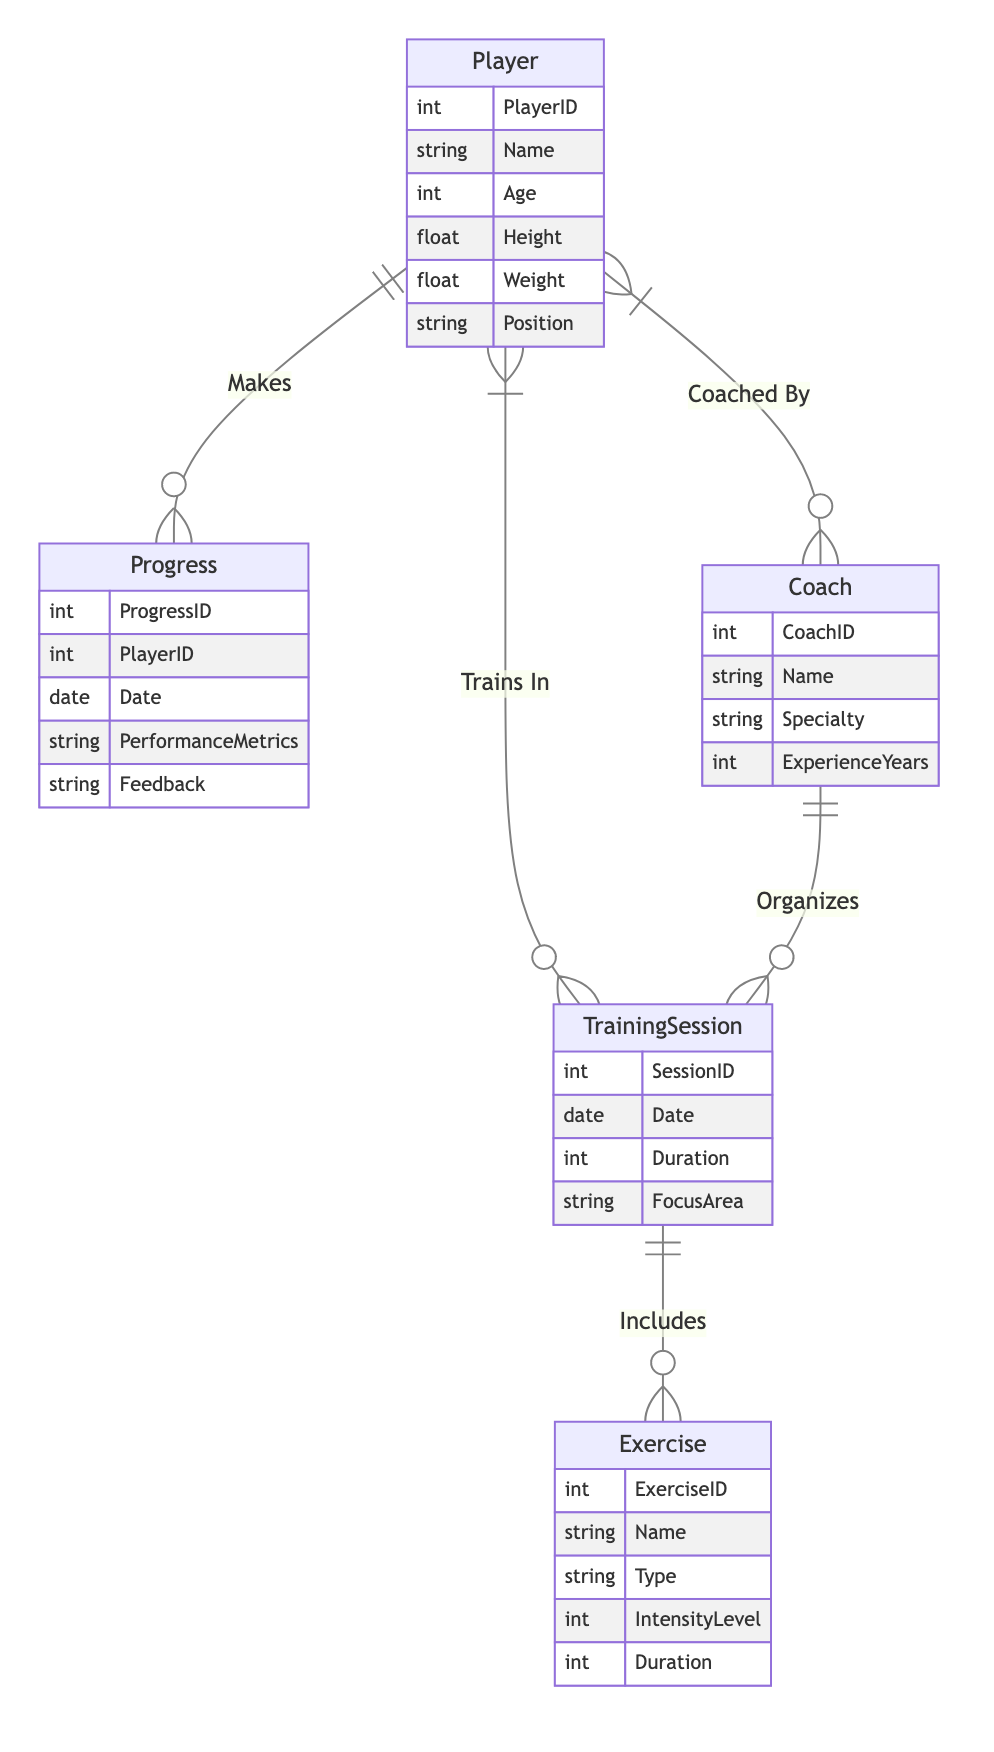What is the relationship between Player and Coach? The diagram indicates a many-to-many relationship between Player and Coach, which means that multiple players can be coached by multiple coaches and vice versa.
Answer: many-to-many How many attributes does the Player entity have? The Player entity consists of six attributes: PlayerID, Name, Age, Height, Weight, and Position.
Answer: six What is the focus area of TrainingSession? The attributes list for TrainingSession includes FocusArea, which indicates that each training session is categorized by a specific focus area, though the specific values are not provided in the diagram.
Answer: FocusArea How many players can be involved in a TrainingSession? Since the diagram shows a many-to-many relationship between Player and TrainingSession, it indicates that multiple players can participate in one training session.
Answer: multiple What type of relationship exists between TrainingSession and Exercise? The relationship defined in the diagram tells us that it is a one-to-many relationship, meaning a single TrainingSession can include multiple Exercises.
Answer: one-to-many What does the Progress entity track for each player? The attributes of the Progress entity include PlayerID, Date, PerformanceMetrics, and Feedback, which suggests that it tracks the performance metrics and feedback specific to a player on a given date.
Answer: performance metrics and feedback How many exercises can be included in a single TrainingSession? The relationship indicates that a single TrainingSession can include multiple Exercises, which arises from the one-to-many relationship specified between TrainingSession and Exercise.
Answer: multiple Which entity is responsible for organizing TrainingSessions? According to the diagram, the Coach entity has a one-to-many relationship with TrainingSession, signifying that one coach can organize several training sessions.
Answer: Coach What is the minimum number of Progress records a Player can have? The diagram shows a one-to-many relationship between Player and Progress, indicating that each player can have zero or more progress records, meaning the minimum is zero.
Answer: zero 